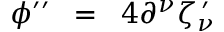<formula> <loc_0><loc_0><loc_500><loc_500>\phi ^ { \prime \prime } \, = \, 4 \partial ^ { \nu } \zeta _ { \nu } ^ { \, \prime }</formula> 